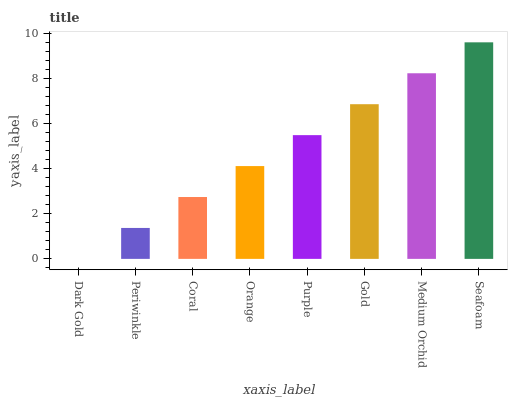Is Dark Gold the minimum?
Answer yes or no. Yes. Is Seafoam the maximum?
Answer yes or no. Yes. Is Periwinkle the minimum?
Answer yes or no. No. Is Periwinkle the maximum?
Answer yes or no. No. Is Periwinkle greater than Dark Gold?
Answer yes or no. Yes. Is Dark Gold less than Periwinkle?
Answer yes or no. Yes. Is Dark Gold greater than Periwinkle?
Answer yes or no. No. Is Periwinkle less than Dark Gold?
Answer yes or no. No. Is Purple the high median?
Answer yes or no. Yes. Is Orange the low median?
Answer yes or no. Yes. Is Orange the high median?
Answer yes or no. No. Is Purple the low median?
Answer yes or no. No. 